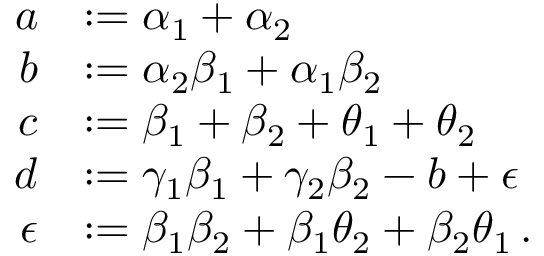Convert formula to latex. <formula><loc_0><loc_0><loc_500><loc_500>\begin{array} { r l } { a } & { \colon = \alpha _ { 1 } + \alpha _ { 2 } } \\ { b } & { \colon = \alpha _ { 2 } \beta _ { 1 } + \alpha _ { 1 } \beta _ { 2 } } \\ { c } & { \colon = \beta _ { 1 } + \beta _ { 2 } + \theta _ { 1 } + \theta _ { 2 } } \\ { d } & { \colon = \gamma _ { 1 } \beta _ { 1 } + \gamma _ { 2 } \beta _ { 2 } - b + \epsilon } \\ { \epsilon } & { \colon = \beta _ { 1 } \beta _ { 2 } + \beta _ { 1 } \theta _ { 2 } + \beta _ { 2 } \theta _ { 1 } \, . } \end{array}</formula> 